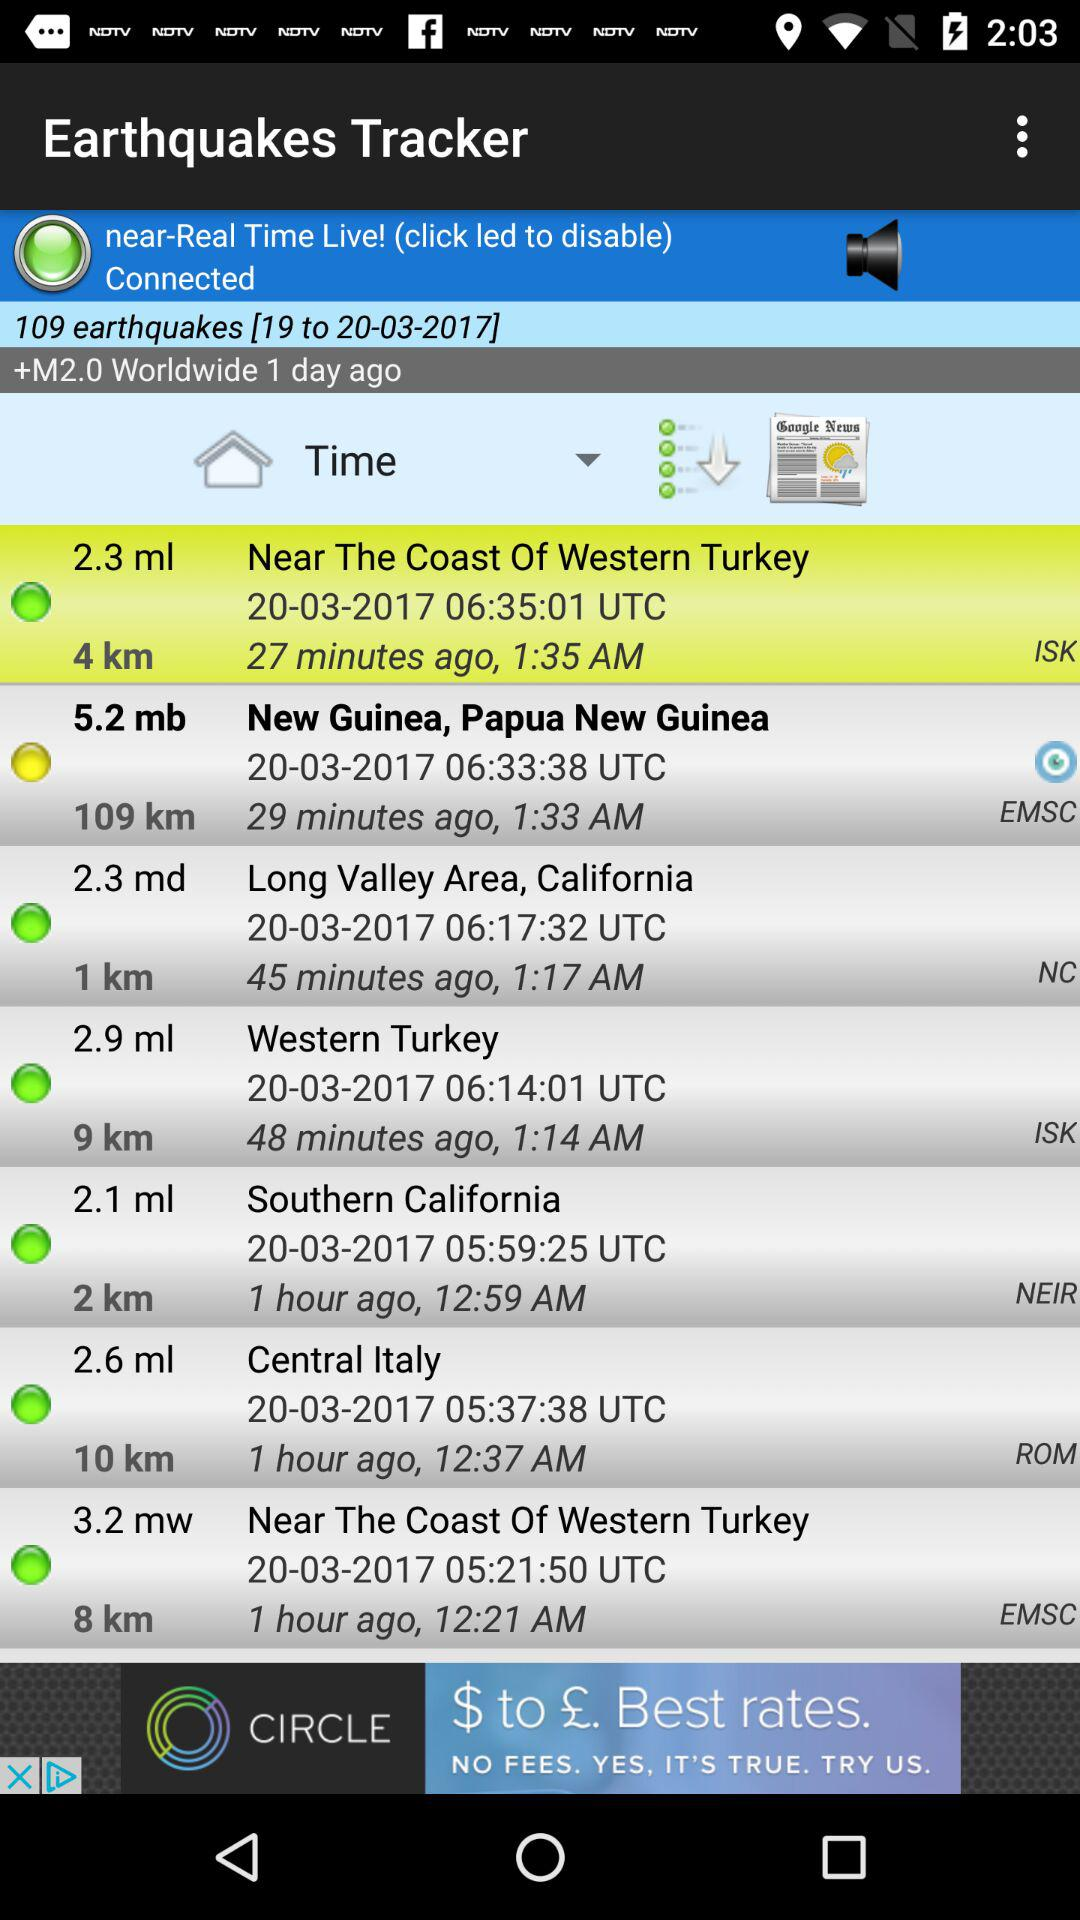What is the date of the earthquakes in central Italy? The date is March 20, 2017. 